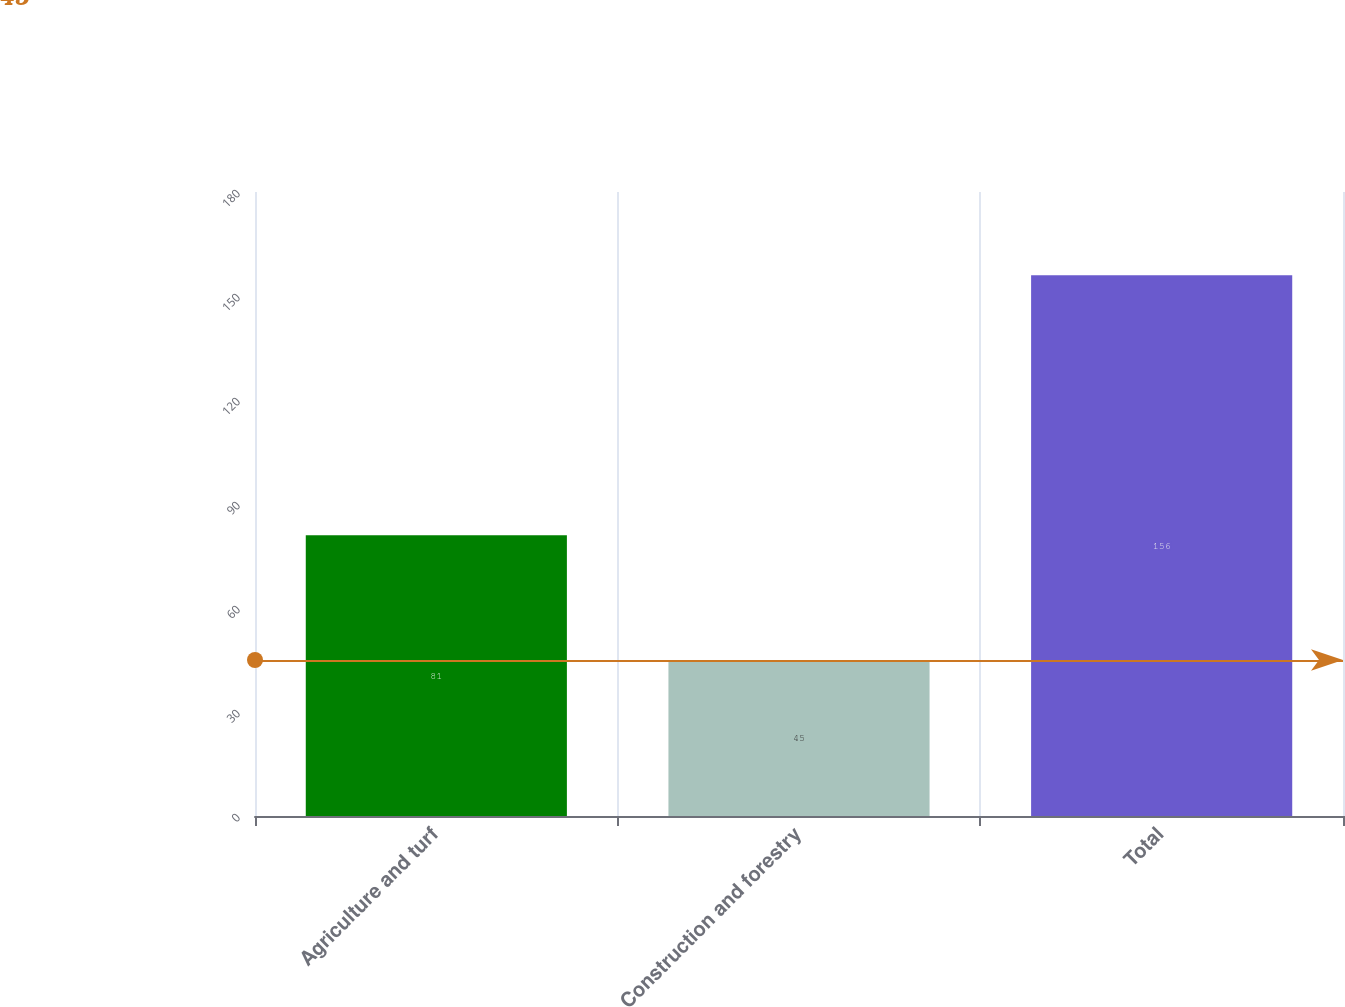Convert chart. <chart><loc_0><loc_0><loc_500><loc_500><bar_chart><fcel>Agriculture and turf<fcel>Construction and forestry<fcel>Total<nl><fcel>81<fcel>45<fcel>156<nl></chart> 